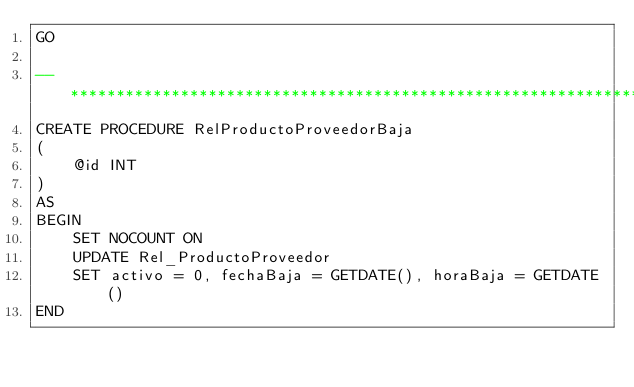Convert code to text. <code><loc_0><loc_0><loc_500><loc_500><_SQL_>GO

--************************************************************************
CREATE PROCEDURE RelProductoProveedorBaja
(
	@id INT
)
AS
BEGIN
	SET NOCOUNT ON
	UPDATE Rel_ProductoProveedor
	SET activo = 0, fechaBaja = GETDATE(), horaBaja = GETDATE()
END</code> 